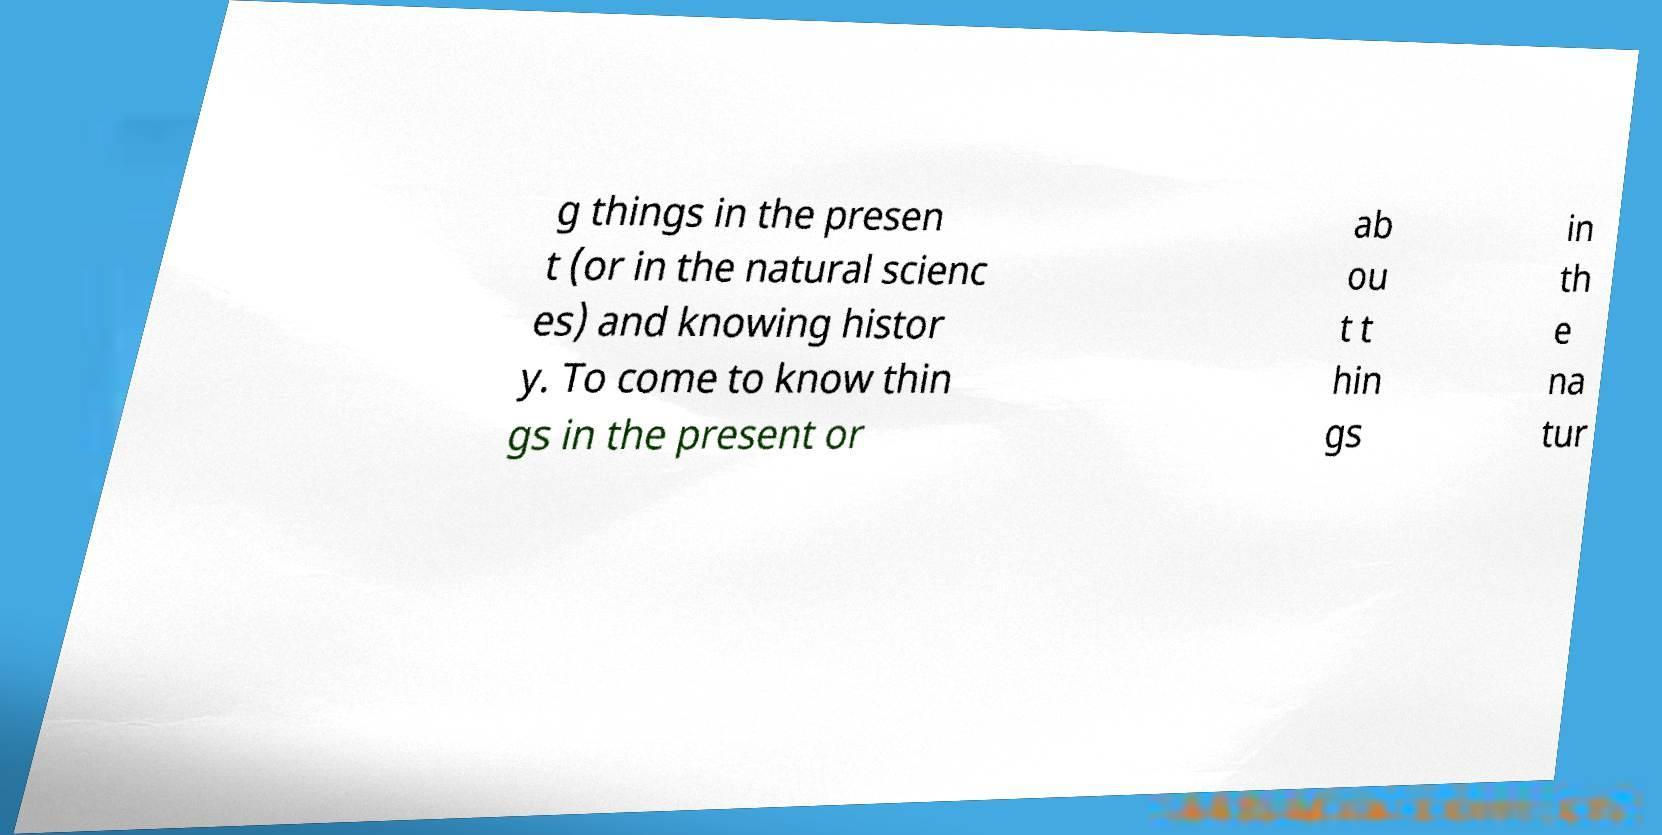Can you accurately transcribe the text from the provided image for me? g things in the presen t (or in the natural scienc es) and knowing histor y. To come to know thin gs in the present or ab ou t t hin gs in th e na tur 